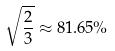Convert formula to latex. <formula><loc_0><loc_0><loc_500><loc_500>\sqrt { \frac { 2 } { 3 } } \approx 8 1 . 6 5 \%</formula> 